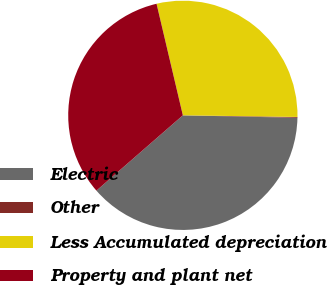<chart> <loc_0><loc_0><loc_500><loc_500><pie_chart><fcel>Electric<fcel>Other<fcel>Less Accumulated depreciation<fcel>Property and plant net<nl><fcel>38.25%<fcel>0.12%<fcel>28.91%<fcel>32.72%<nl></chart> 